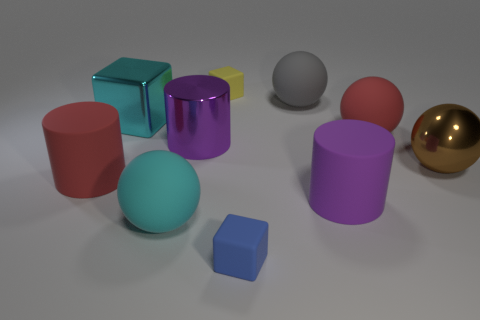Is the number of large objects behind the large cyan cube less than the number of big purple metal things?
Provide a short and direct response. No. Do the big cube and the metallic cylinder have the same color?
Keep it short and to the point. No. What size is the gray thing?
Provide a short and direct response. Large. What number of tiny rubber objects are the same color as the big metal ball?
Make the answer very short. 0. Is there a matte object behind the large metal object that is on the right side of the small cube that is in front of the red cylinder?
Provide a short and direct response. Yes. The purple matte thing that is the same size as the red sphere is what shape?
Provide a succinct answer. Cylinder. What number of large things are either brown spheres or purple matte objects?
Give a very brief answer. 2. What color is the other small block that is the same material as the tiny blue cube?
Make the answer very short. Yellow. There is a small object that is in front of the big cyan metal block; is it the same shape as the large purple object that is to the left of the big gray rubber ball?
Offer a terse response. No. How many shiny objects are either small red cylinders or big things?
Give a very brief answer. 3. 